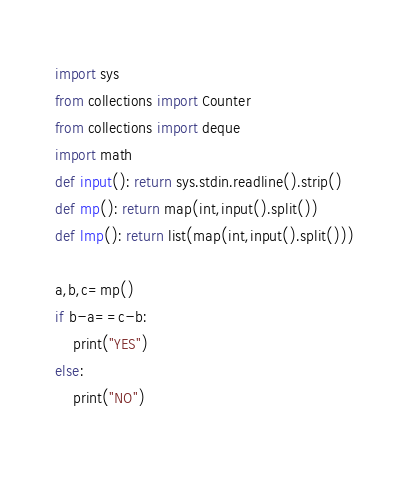Convert code to text. <code><loc_0><loc_0><loc_500><loc_500><_Python_>import sys
from collections import Counter
from collections import deque
import math
def input(): return sys.stdin.readline().strip()
def mp(): return map(int,input().split())
def lmp(): return list(map(int,input().split()))

a,b,c=mp()
if b-a==c-b:
    print("YES")
else:
    print("NO")
    </code> 